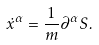Convert formula to latex. <formula><loc_0><loc_0><loc_500><loc_500>\dot { x } ^ { \alpha } = \frac { 1 } { m } \partial ^ { \alpha } S .</formula> 